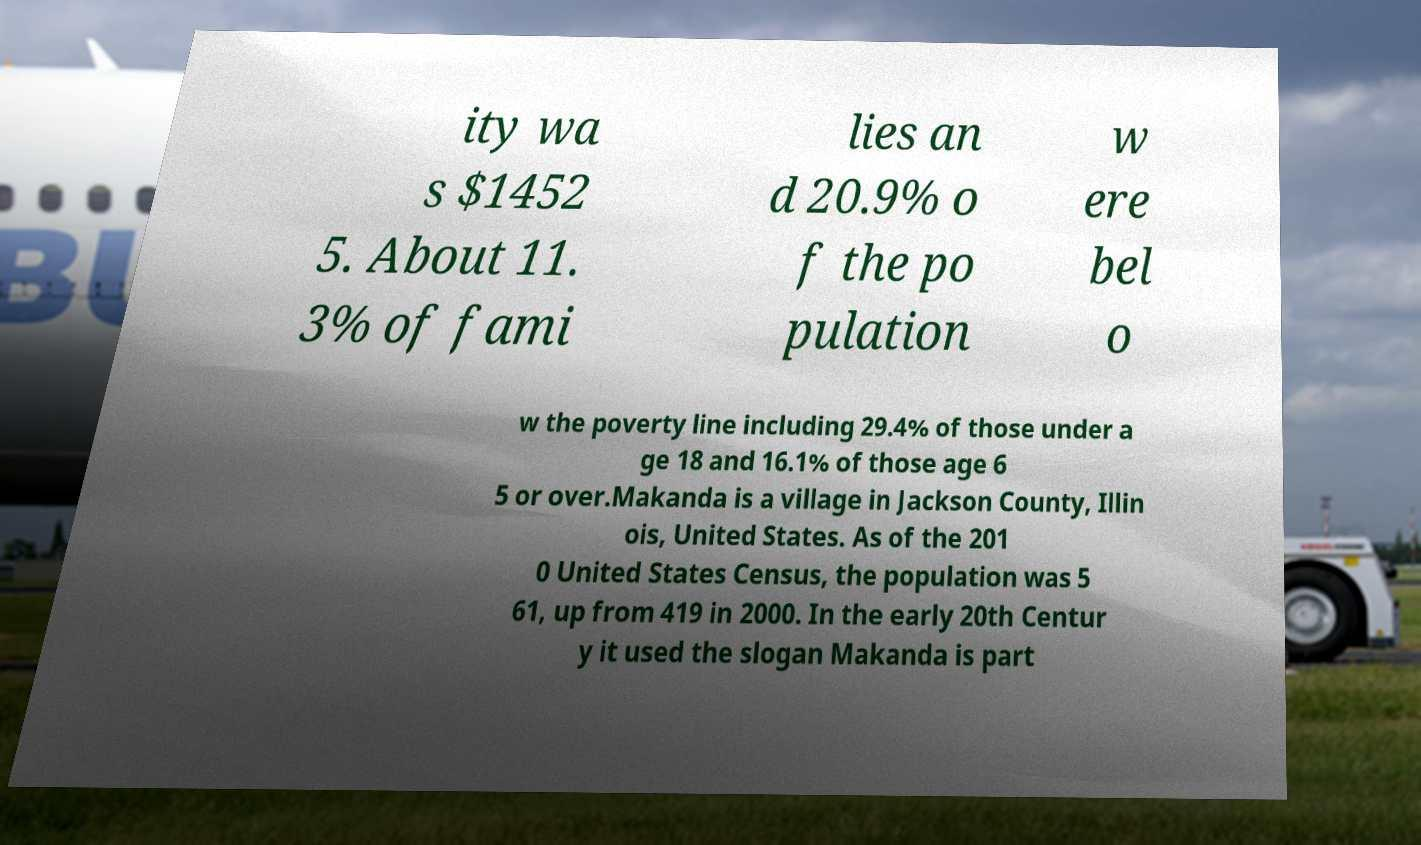Please read and relay the text visible in this image. What does it say? ity wa s $1452 5. About 11. 3% of fami lies an d 20.9% o f the po pulation w ere bel o w the poverty line including 29.4% of those under a ge 18 and 16.1% of those age 6 5 or over.Makanda is a village in Jackson County, Illin ois, United States. As of the 201 0 United States Census, the population was 5 61, up from 419 in 2000. In the early 20th Centur y it used the slogan Makanda is part 